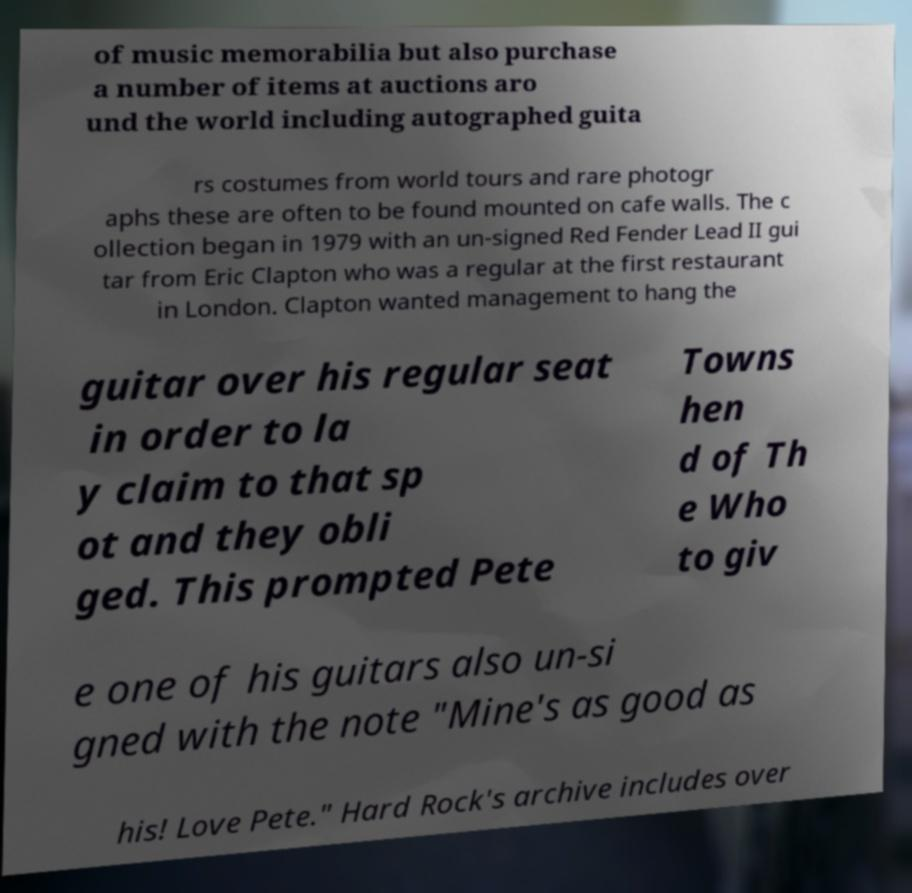Can you accurately transcribe the text from the provided image for me? of music memorabilia but also purchase a number of items at auctions aro und the world including autographed guita rs costumes from world tours and rare photogr aphs these are often to be found mounted on cafe walls. The c ollection began in 1979 with an un-signed Red Fender Lead II gui tar from Eric Clapton who was a regular at the first restaurant in London. Clapton wanted management to hang the guitar over his regular seat in order to la y claim to that sp ot and they obli ged. This prompted Pete Towns hen d of Th e Who to giv e one of his guitars also un-si gned with the note "Mine's as good as his! Love Pete." Hard Rock's archive includes over 